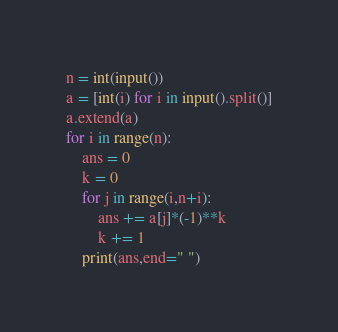Convert code to text. <code><loc_0><loc_0><loc_500><loc_500><_Python_>n = int(input())
a = [int(i) for i in input().split()]
a.extend(a)
for i in range(n):
    ans = 0
    k = 0
    for j in range(i,n+i):
        ans += a[j]*(-1)**k
        k += 1
    print(ans,end=" ")</code> 